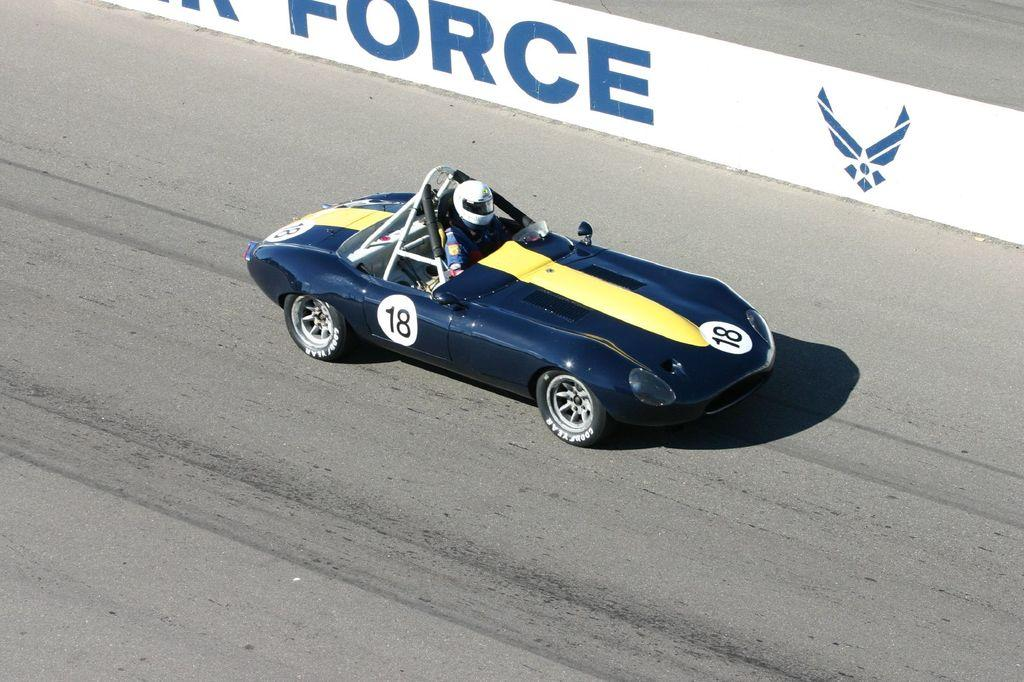What is the person in the image doing? The person is sitting in an auto racing car in the image. Where is the car located? The car is on the road. What type of clothing is the person wearing? The person is wearing a jacket and a helmet. What can be inferred about the purpose of the image? The image appears to be a hoarding. What type of beast can be seen flying in the image? There is no beast present in the image, nor is there any indication of a flying creature. 